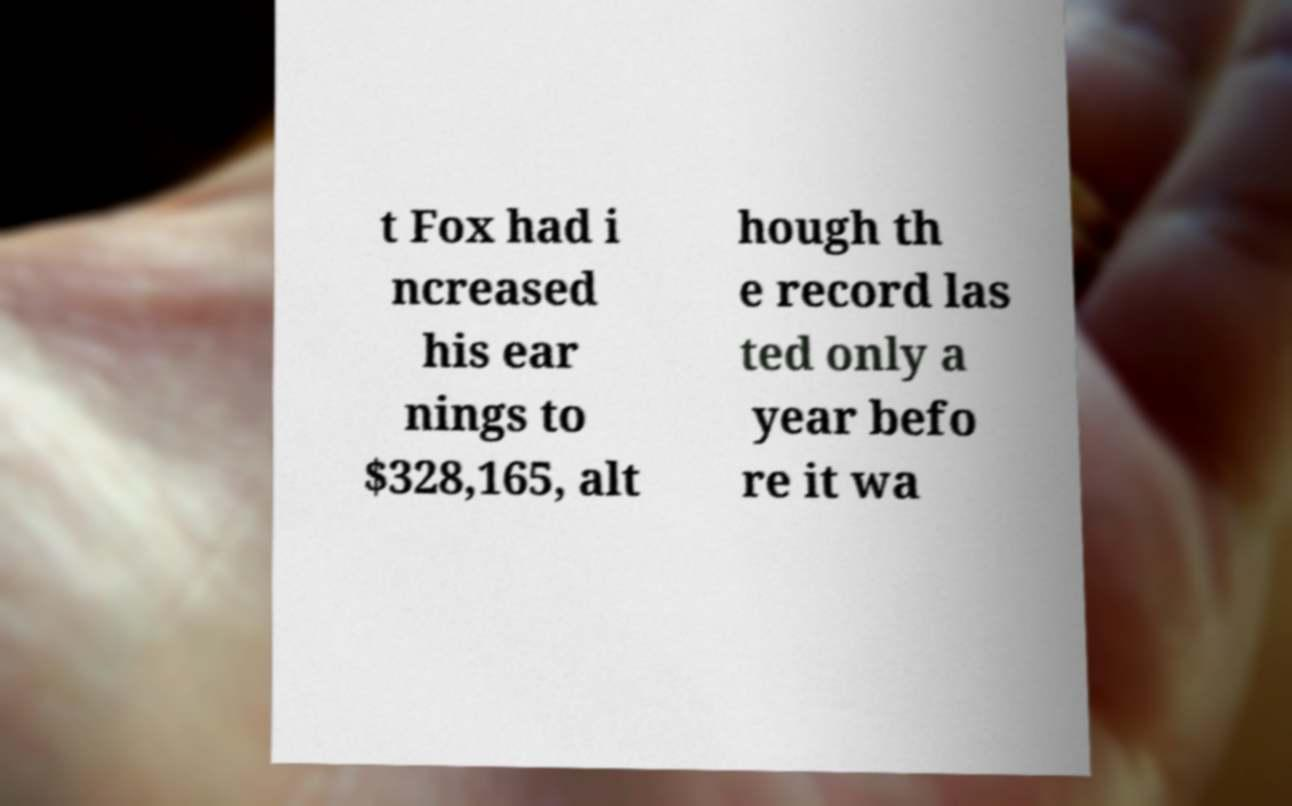Could you extract and type out the text from this image? t Fox had i ncreased his ear nings to $328,165, alt hough th e record las ted only a year befo re it wa 